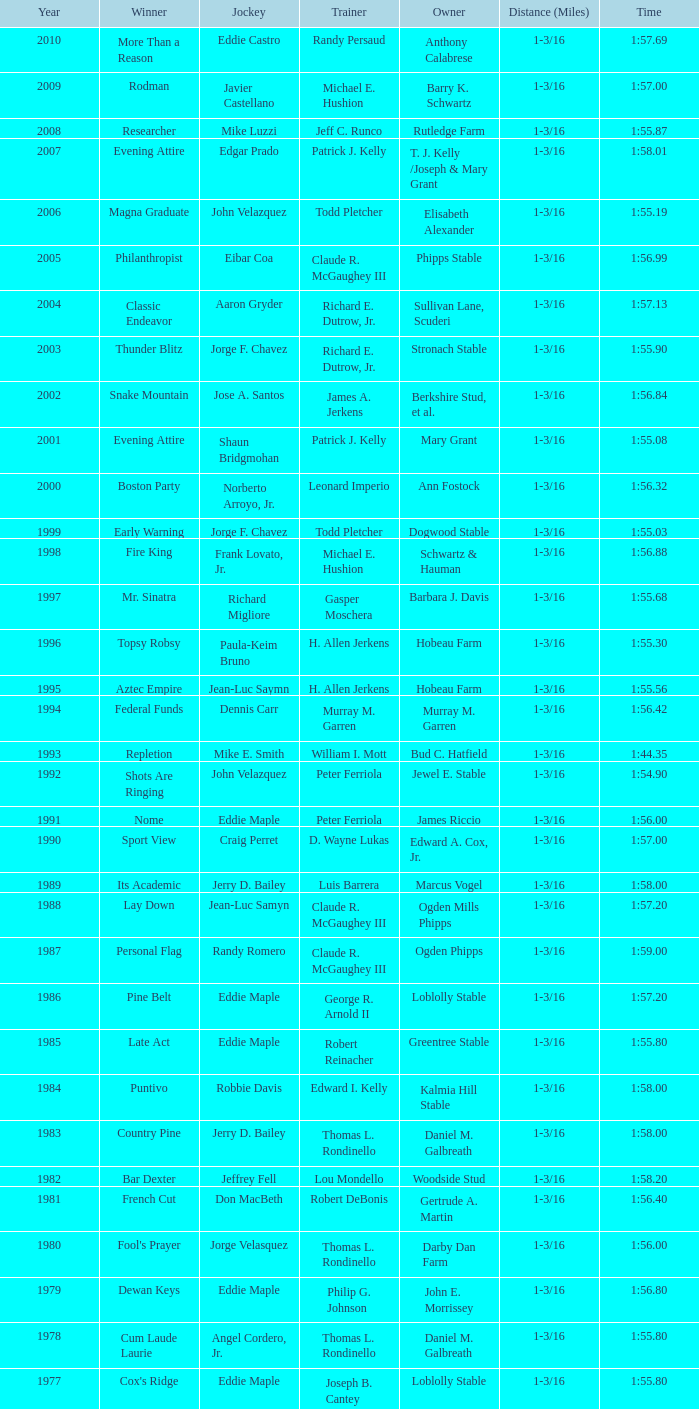Would you mind parsing the complete table? {'header': ['Year', 'Winner', 'Jockey', 'Trainer', 'Owner', 'Distance (Miles)', 'Time'], 'rows': [['2010', 'More Than a Reason', 'Eddie Castro', 'Randy Persaud', 'Anthony Calabrese', '1-3/16', '1:57.69'], ['2009', 'Rodman', 'Javier Castellano', 'Michael E. Hushion', 'Barry K. Schwartz', '1-3/16', '1:57.00'], ['2008', 'Researcher', 'Mike Luzzi', 'Jeff C. Runco', 'Rutledge Farm', '1-3/16', '1:55.87'], ['2007', 'Evening Attire', 'Edgar Prado', 'Patrick J. Kelly', 'T. J. Kelly /Joseph & Mary Grant', '1-3/16', '1:58.01'], ['2006', 'Magna Graduate', 'John Velazquez', 'Todd Pletcher', 'Elisabeth Alexander', '1-3/16', '1:55.19'], ['2005', 'Philanthropist', 'Eibar Coa', 'Claude R. McGaughey III', 'Phipps Stable', '1-3/16', '1:56.99'], ['2004', 'Classic Endeavor', 'Aaron Gryder', 'Richard E. Dutrow, Jr.', 'Sullivan Lane, Scuderi', '1-3/16', '1:57.13'], ['2003', 'Thunder Blitz', 'Jorge F. Chavez', 'Richard E. Dutrow, Jr.', 'Stronach Stable', '1-3/16', '1:55.90'], ['2002', 'Snake Mountain', 'Jose A. Santos', 'James A. Jerkens', 'Berkshire Stud, et al.', '1-3/16', '1:56.84'], ['2001', 'Evening Attire', 'Shaun Bridgmohan', 'Patrick J. Kelly', 'Mary Grant', '1-3/16', '1:55.08'], ['2000', 'Boston Party', 'Norberto Arroyo, Jr.', 'Leonard Imperio', 'Ann Fostock', '1-3/16', '1:56.32'], ['1999', 'Early Warning', 'Jorge F. Chavez', 'Todd Pletcher', 'Dogwood Stable', '1-3/16', '1:55.03'], ['1998', 'Fire King', 'Frank Lovato, Jr.', 'Michael E. Hushion', 'Schwartz & Hauman', '1-3/16', '1:56.88'], ['1997', 'Mr. Sinatra', 'Richard Migliore', 'Gasper Moschera', 'Barbara J. Davis', '1-3/16', '1:55.68'], ['1996', 'Topsy Robsy', 'Paula-Keim Bruno', 'H. Allen Jerkens', 'Hobeau Farm', '1-3/16', '1:55.30'], ['1995', 'Aztec Empire', 'Jean-Luc Saymn', 'H. Allen Jerkens', 'Hobeau Farm', '1-3/16', '1:55.56'], ['1994', 'Federal Funds', 'Dennis Carr', 'Murray M. Garren', 'Murray M. Garren', '1-3/16', '1:56.42'], ['1993', 'Repletion', 'Mike E. Smith', 'William I. Mott', 'Bud C. Hatfield', '1-3/16', '1:44.35'], ['1992', 'Shots Are Ringing', 'John Velazquez', 'Peter Ferriola', 'Jewel E. Stable', '1-3/16', '1:54.90'], ['1991', 'Nome', 'Eddie Maple', 'Peter Ferriola', 'James Riccio', '1-3/16', '1:56.00'], ['1990', 'Sport View', 'Craig Perret', 'D. Wayne Lukas', 'Edward A. Cox, Jr.', '1-3/16', '1:57.00'], ['1989', 'Its Academic', 'Jerry D. Bailey', 'Luis Barrera', 'Marcus Vogel', '1-3/16', '1:58.00'], ['1988', 'Lay Down', 'Jean-Luc Samyn', 'Claude R. McGaughey III', 'Ogden Mills Phipps', '1-3/16', '1:57.20'], ['1987', 'Personal Flag', 'Randy Romero', 'Claude R. McGaughey III', 'Ogden Phipps', '1-3/16', '1:59.00'], ['1986', 'Pine Belt', 'Eddie Maple', 'George R. Arnold II', 'Loblolly Stable', '1-3/16', '1:57.20'], ['1985', 'Late Act', 'Eddie Maple', 'Robert Reinacher', 'Greentree Stable', '1-3/16', '1:55.80'], ['1984', 'Puntivo', 'Robbie Davis', 'Edward I. Kelly', 'Kalmia Hill Stable', '1-3/16', '1:58.00'], ['1983', 'Country Pine', 'Jerry D. Bailey', 'Thomas L. Rondinello', 'Daniel M. Galbreath', '1-3/16', '1:58.00'], ['1982', 'Bar Dexter', 'Jeffrey Fell', 'Lou Mondello', 'Woodside Stud', '1-3/16', '1:58.20'], ['1981', 'French Cut', 'Don MacBeth', 'Robert DeBonis', 'Gertrude A. Martin', '1-3/16', '1:56.40'], ['1980', "Fool's Prayer", 'Jorge Velasquez', 'Thomas L. Rondinello', 'Darby Dan Farm', '1-3/16', '1:56.00'], ['1979', 'Dewan Keys', 'Eddie Maple', 'Philip G. Johnson', 'John E. Morrissey', '1-3/16', '1:56.80'], ['1978', 'Cum Laude Laurie', 'Angel Cordero, Jr.', 'Thomas L. Rondinello', 'Daniel M. Galbreath', '1-3/16', '1:55.80'], ['1977', "Cox's Ridge", 'Eddie Maple', 'Joseph B. Cantey', 'Loblolly Stable', '1-3/16', '1:55.80'], ['1976', "It's Freezing", 'Jacinto Vasquez', 'Anthony Basile', 'Bwamazon Farm', '1-3/16', '1:56.60'], ['1975', 'Hail The Pirates', 'Ron Turcotte', 'Thomas L. Rondinello', 'Daniel M. Galbreath', '1-3/16', '1:55.60'], ['1974', 'Free Hand', 'Jose Amy', 'Pancho Martin', 'Sigmund Sommer', '1-3/16', '1:55.00'], ['1973', 'True Knight', 'Angel Cordero, Jr.', 'Thomas L. Rondinello', 'Darby Dan Farm', '1-3/16', '1:55.00'], ['1972', 'Sunny And Mild', 'Michael Venezia', 'W. Preston King', 'Harry Rogosin', '1-3/16', '1:54.40'], ['1971', 'Red Reality', 'Jorge Velasquez', 'MacKenzie Miller', 'Cragwood Stables', '1-1/8', '1:49.60'], ['1970', 'Best Turn', 'Larry Adams', 'Reggie Cornell', 'Calumet Farm', '1-1/8', '1:50.00'], ['1969', 'Vif', 'Larry Adams', 'Clarence Meaux', 'Harvey Peltier', '1-1/8', '1:49.20'], ['1968', 'Irish Dude', 'Sandino Hernandez', 'Jack Bradley', 'Richard W. Taylor', '1-1/8', '1:49.60'], ['1967', 'Mr. Right', 'Heliodoro Gustines', 'Evan S. Jackson', 'Mrs. Peter Duchin', '1-1/8', '1:49.60'], ['1966', 'Amberoid', 'Walter Blum', 'Lucien Laurin', 'Reginald N. Webster', '1-1/8', '1:50.60'], ['1965', 'Prairie Schooner', 'Eddie Belmonte', 'James W. Smith', 'High Tide Stable', '1-1/8', '1:50.20'], ['1964', 'Third Martini', 'William Boland', 'H. Allen Jerkens', 'Hobeau Farm', '1-1/8', '1:50.60'], ['1963', 'Uppercut', 'Manuel Ycaza', 'Willard C. Freeman', 'William Harmonay', '1-1/8', '1:35.40'], ['1962', 'Grid Iron Hero', 'Manuel Ycaza', 'Laz Barrera', 'Emil Dolce', '1 mile', '1:34.00'], ['1961', 'Manassa Mauler', 'Braulio Baeza', 'Pancho Martin', 'Emil Dolce', '1 mile', '1:36.20'], ['1960', 'Cranberry Sauce', 'Heliodoro Gustines', 'not found', 'Elmendorf Farm', '1 mile', '1:36.20'], ['1959', 'Whitley', 'Eric Guerin', 'Max Hirsch', 'W. Arnold Hanger', '1 mile', '1:36.40'], ['1958', 'Oh Johnny', 'William Boland', 'Norman R. McLeod', 'Mrs. Wallace Gilroy', '1-1/16', '1:43.40'], ['1957', 'Bold Ruler', 'Eddie Arcaro', 'James E. Fitzsimmons', 'Wheatley Stable', '1-1/16', '1:42.80'], ['1956', 'Blessbull', 'Willie Lester', 'not found', 'Morris Sims', '1-1/16', '1:42.00'], ['1955', 'Fabulist', 'Ted Atkinson', 'William C. Winfrey', 'High Tide Stable', '1-1/16', '1:43.60'], ['1954', 'Find', 'Eric Guerin', 'William C. Winfrey', 'Alfred G. Vanderbilt II', '1-1/16', '1:44.00'], ['1953', 'Flaunt', 'S. Cole', 'Hubert W. Williams', 'Arnold Skjeveland', '1-1/16', '1:44.20'], ['1952', 'County Delight', 'Dave Gorman', 'James E. Ryan', 'Rokeby Stable', '1-1/16', '1:43.60'], ['1951', 'Sheilas Reward', 'Ovie Scurlock', 'Eugene Jacobs', 'Mrs. Louis Lazare', '1-1/16', '1:44.60'], ['1950', 'Three Rings', 'Hedley Woodhouse', 'Willie Knapp', 'Mrs. Evelyn L. Hopkins', '1-1/16', '1:44.60'], ['1949', 'Three Rings', 'Ted Atkinson', 'Willie Knapp', 'Mrs. Evelyn L. Hopkins', '1-1/16', '1:47.40'], ['1948', 'Knockdown', 'Ferrill Zufelt', 'Tom Smith', 'Maine Chance Farm', '1-1/16', '1:44.60'], ['1947', 'Gallorette', 'Job Dean Jessop', 'Edward A. Christmas', 'William L. Brann', '1-1/16', '1:45.40'], ['1946', 'Helioptic', 'Paul Miller', 'not found', 'William Goadby Loew', '1-1/16', '1:43.20'], ['1945', 'Olympic Zenith', 'Conn McCreary', 'Willie Booth', 'William G. Helis', '1-1/16', '1:45.60'], ['1944', 'First Fiddle', 'Johnny Longden', 'Edward Mulrenan', 'Mrs. Edward Mulrenan', '1-1/16', '1:44.20'], ['1943', 'The Rhymer', 'Conn McCreary', 'John M. Gaver, Sr.', 'Greentree Stable', '1-1/16', '1:45.00'], ['1942', 'Waller', 'Billie Thompson', 'A. G. Robertson', 'John C. Clark', '1-1/16', '1:44.00'], ['1941', 'Salford II', 'Don Meade', 'not found', 'Ralph B. Strassburger', '1-1/16', '1:44.20'], ['1940', 'He Did', 'Eddie Arcaro', 'J. Thomas Taylor', 'W. Arnold Hanger', '1-1/16', '1:43.20'], ['1939', 'Lovely Night', 'Johnny Longden', 'Henry McDaniel', 'Mrs. F. Ambrose Clark', '1 mile', '1:36.40'], ['1938', 'War Admiral', 'Charles Kurtsinger', 'George Conway', 'Glen Riddle Farm', '1 mile', '1:36.80'], ['1937', 'Snark', 'Johnny Longden', 'James E. Fitzsimmons', 'Wheatley Stable', '1 mile', '1:37.40'], ['1936', 'Good Gamble', 'Samuel Renick', 'Bud Stotler', 'Alfred G. Vanderbilt II', '1 mile', '1:37.20'], ['1935', 'King Saxon', 'Calvin Rainey', 'Charles Shaw', 'C. H. Knebelkamp', '1 mile', '1:37.20'], ['1934', 'Singing Wood', 'Robert Jones', 'James W. Healy', 'Liz Whitney', '1 mile', '1:38.60'], ['1933', 'Kerry Patch', 'Robert Wholey', 'Joseph A. Notter', 'Lee Rosenberg', '1 mile', '1:38.00'], ['1932', 'Halcyon', 'Hank Mills', 'T. J. Healey', 'C. V. Whitney', '1 mile', '1:38.00'], ['1931', 'Halcyon', 'G. Rose', 'T. J. Healey', 'C. V. Whitney', '1 mile', '1:38.40'], ['1930', 'Kildare', 'John Passero', 'Norman Tallman', 'Newtondale Stable', '1 mile', '1:38.60'], ['1929', 'Comstockery', 'Sidney Hebert', 'Thomas W. Murphy', 'Greentree Stable', '1 mile', '1:39.60'], ['1928', 'Kentucky II', 'George Schreiner', 'Max Hirsch', 'A. Charles Schwartz', '1 mile', '1:38.80'], ['1927', 'Light Carbine', 'James McCoy', 'M. J. Dunlevy', 'I. B. Humphreys', '1 mile', '1:36.80'], ['1926', 'Macaw', 'Linus McAtee', 'James G. Rowe, Sr.', 'Harry Payne Whitney', '1 mile', '1:37.00'], ['1925', 'Mad Play', 'Laverne Fator', 'Sam Hildreth', 'Rancocas Stable', '1 mile', '1:36.60'], ['1924', 'Mad Hatter', 'Earl Sande', 'Sam Hildreth', 'Rancocas Stable', '1 mile', '1:36.60'], ['1923', 'Zev', 'Earl Sande', 'Sam Hildreth', 'Rancocas Stable', '1 mile', '1:37.00'], ['1922', 'Grey Lag', 'Laverne Fator', 'Sam Hildreth', 'Rancocas Stable', '1 mile', '1:38.00'], ['1921', 'John P. Grier', 'Frank Keogh', 'James G. Rowe, Sr.', 'Harry Payne Whitney', '1 mile', '1:36.00'], ['1920', 'Cirrus', 'Lavelle Ensor', 'Sam Hildreth', 'Sam Hildreth', '1 mile', '1:38.00'], ['1919', 'Star Master', 'Merritt Buxton', 'Walter B. Jennings', 'A. Kingsley Macomber', '1 mile', '1:37.60'], ['1918', 'Roamer', 'Lawrence Lyke', 'A. J. Goldsborough', 'Andrew Miller', '1 mile', '1:36.60'], ['1917', 'Old Rosebud', 'Frank Robinson', 'Frank D. Weir', 'F. D. Weir & Hamilton C. Applegate', '1 mile', '1:37.60'], ['1916', 'Short Grass', 'Frank Keogh', 'not found', 'Emil Herz', '1 mile', '1:36.40'], ['1915', 'Roamer', 'James Butwell', 'A. J. Goldsborough', 'Andrew Miller', '1 mile', '1:39.20'], ['1914', 'Flying Fairy', 'Tommy Davies', 'J. Simon Healy', 'Edward B. Cassatt', '1 mile', '1:42.20'], ['1913', 'No Race', 'No Race', 'No Race', 'No Race', '1 mile', 'no race'], ['1912', 'No Race', 'No Race', 'No Race', 'No Race', '1 mile', 'no race'], ['1911', 'No Race', 'No Race', 'No Race', 'No Race', '1 mile', 'no race'], ['1910', 'Arasee', 'Buddy Glass', 'Andrew G. Blakely', 'Samuel Emery', '1 mile', '1:39.80'], ['1909', 'No Race', 'No Race', 'No Race', 'No Race', '1 mile', 'no race'], ['1908', 'Jack Atkin', 'Phil Musgrave', 'Herman R. Brandt', 'Barney Schreiber', '1 mile', '1:39.00'], ['1907', 'W. H. Carey', 'George Mountain', 'James Blute', 'Richard F. Carman', '1 mile', '1:40.00'], ['1906', "Ram's Horn", 'L. Perrine', 'W. S. "Jim" Williams', 'W. S. "Jim" Williams', '1 mile', '1:39.40'], ['1905', 'St. Valentine', 'William Crimmins', 'John Shields', 'Alexander Shields', '1 mile', '1:39.20'], ['1904', 'Rosetint', 'Thomas H. Burns', 'James Boden', 'John Boden', '1 mile', '1:39.20'], ['1903', 'Yellow Tail', 'Willie Shaw', 'H. E. Rowell', 'John Hackett', '1m 70yds', '1:45.20'], ['1902', 'Margravite', 'Otto Wonderly', 'not found', 'Charles Fleischmann Sons', '1m 70 yds', '1:46.00']]} What was the time recorded by kentucky ii when it won the race? 1:38.80. 